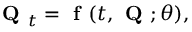<formula> <loc_0><loc_0><loc_500><loc_500>Q _ { t } = { f } ( t , Q ; \theta ) ,</formula> 